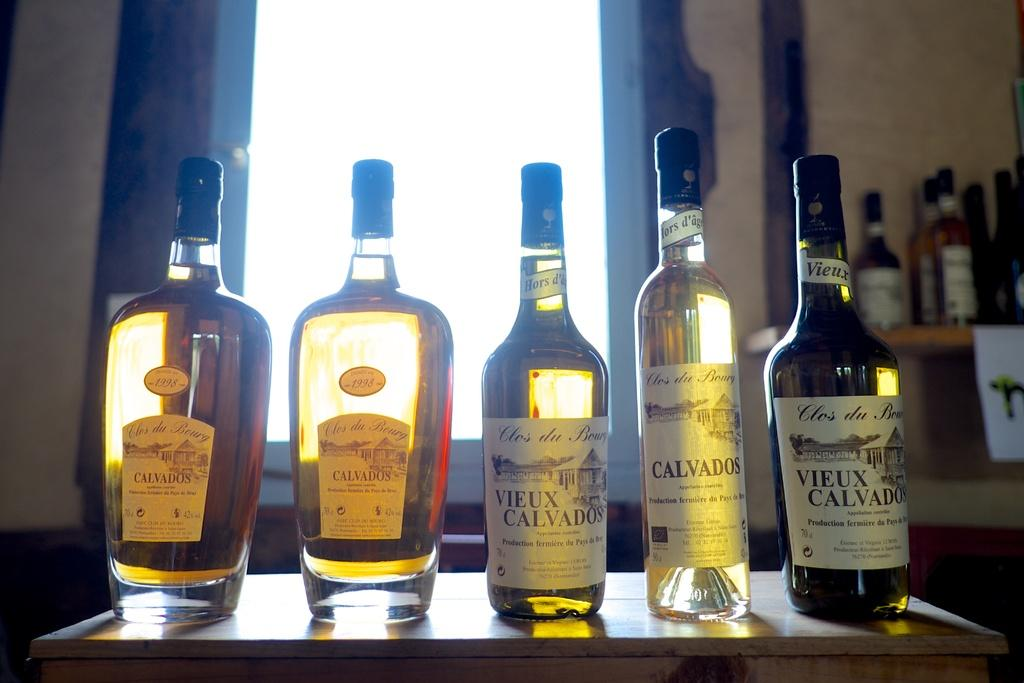Provide a one-sentence caption for the provided image. five assorted bottles of Calvados sit on a table in front of a window. 